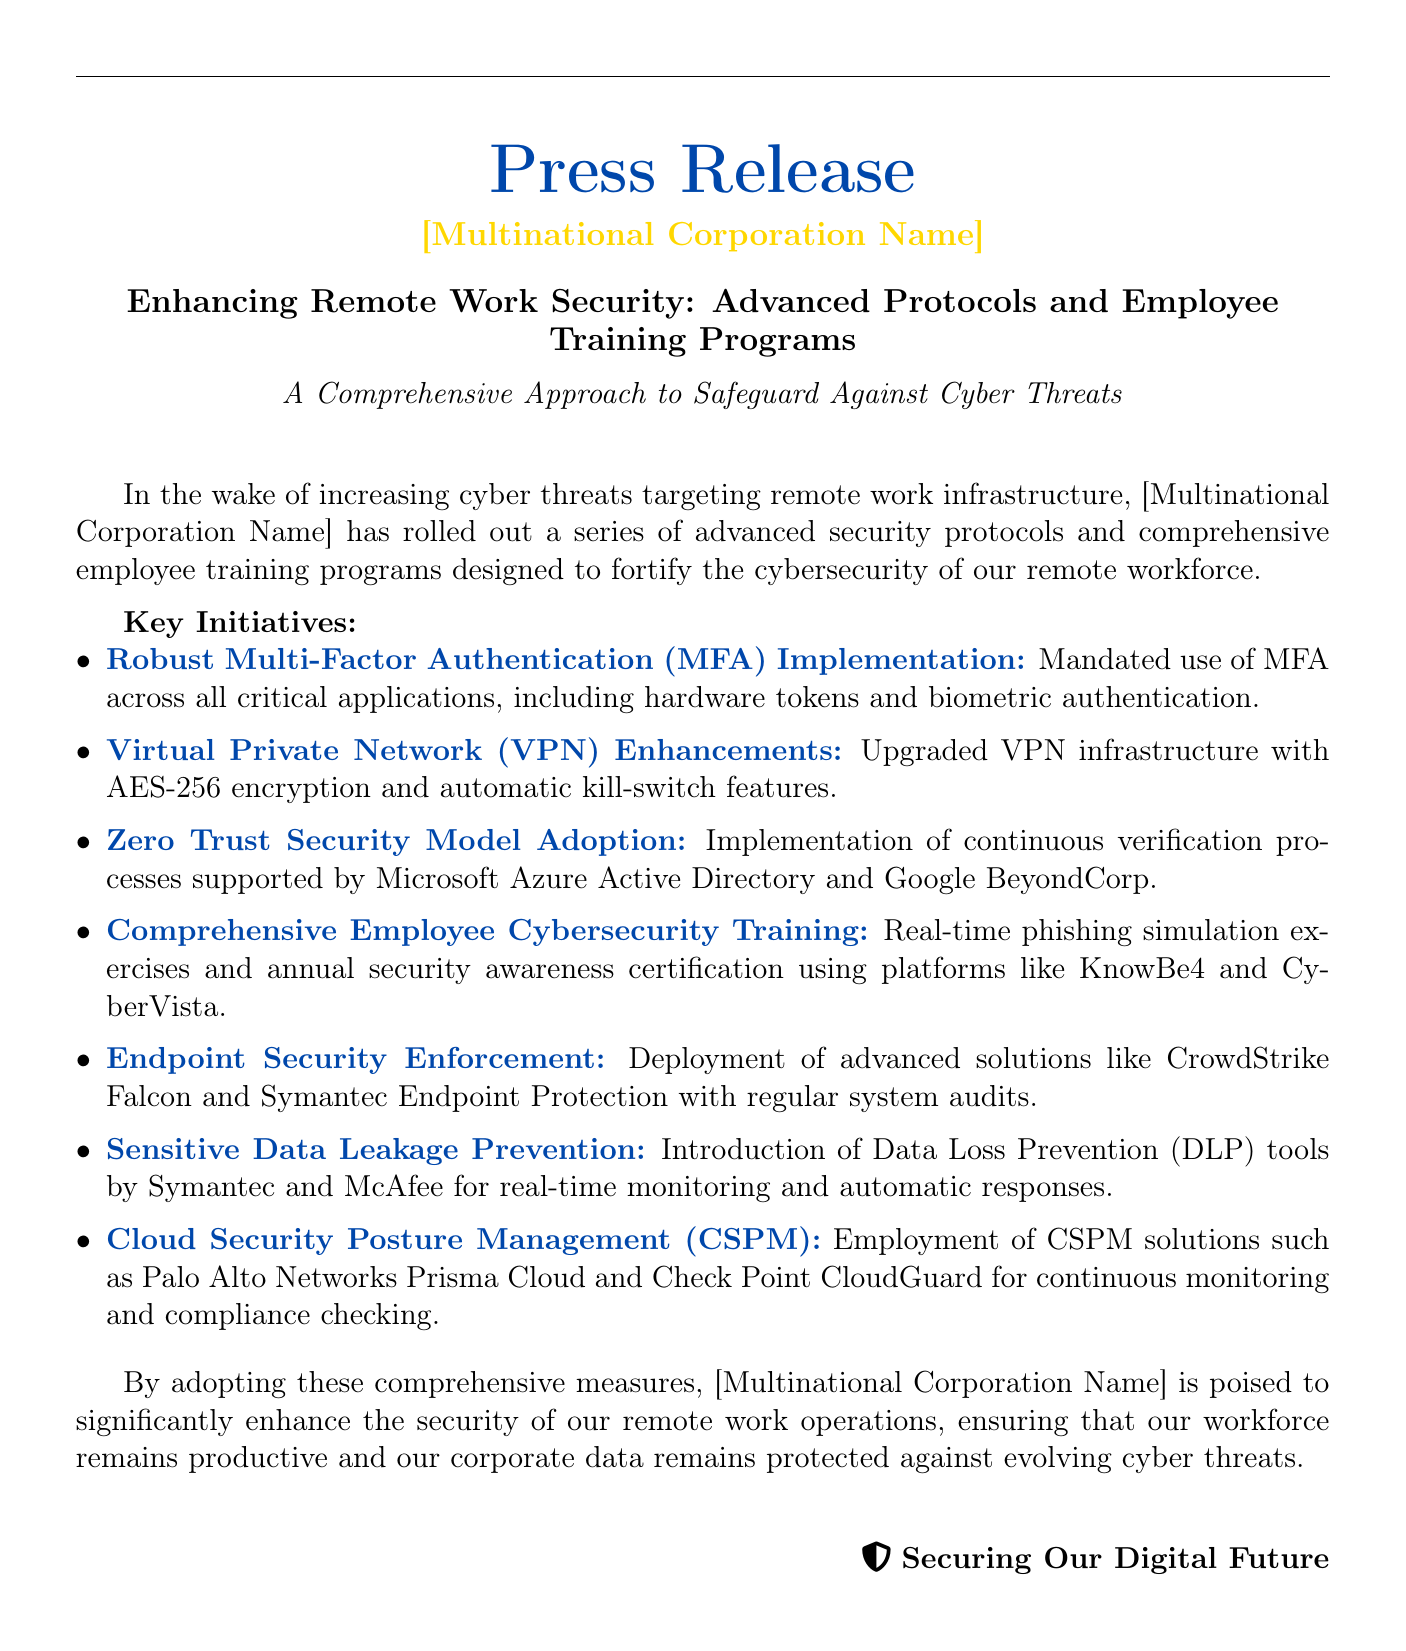What is the title of the press release? The title of the press release is presented prominently at the beginning of the document, detailing the focus on security measures.
Answer: Enhancing Remote Work Security: Advanced Protocols and Employee Training Programs What kind of authentication is mandated? The document specifies that a certain type of security measure is required across all critical applications, enhancing protection.
Answer: Multi-Factor Authentication (MFA) Which encryption standard is mentioned for the VPN? The document lists a specific encryption standard used to enhance VPN security, indicating a high level of data protection.
Answer: AES-256 What training platform is used for employee cybersecurity training? The text mentions specific platforms utilized for training employees on cybersecurity, contributing to a better trained workforce.
Answer: KnowBe4 and CyberVista How many key initiatives are listed? The document outlines the essential measures taken by the corporation, allowing readers to understand the extent of the response.
Answer: Seven What model is adopted for security verification? An advanced security framework is mentioned, suggesting a cutting-edge approach to managing threats and ensuring security is robust.
Answer: Zero Trust Security Model Which tools are introduced for data leakage prevention? The document specifies certain tools aimed at monitoring data flow and preventing unauthorized access or leaks, enhancing data security.
Answer: Symantec and McAfee What is the overarching goal of the corporation's initiatives? The text concludes with the main objective behind implementing these measures, reflecting the corporation's commitment to security and productivity.
Answer: Enhance the security of remote work operations 